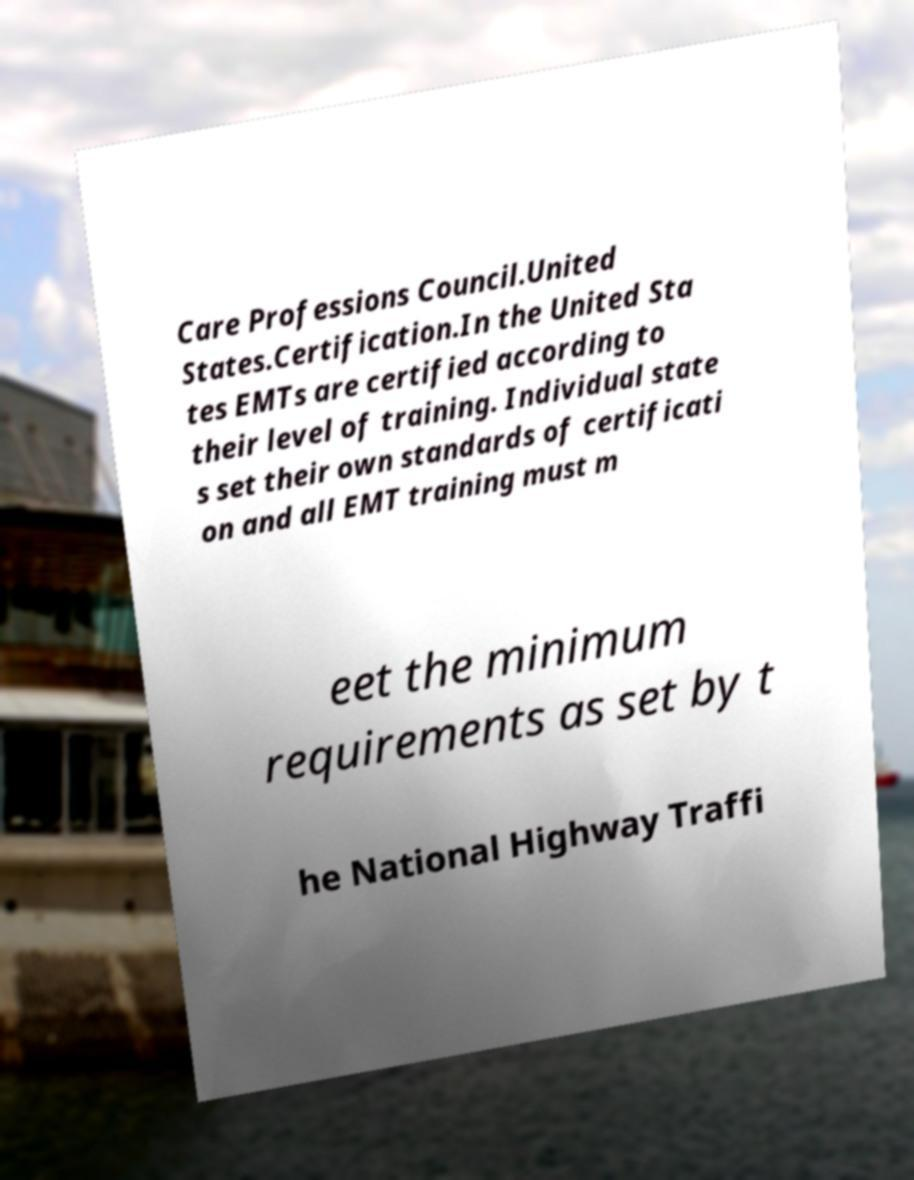Could you extract and type out the text from this image? Care Professions Council.United States.Certification.In the United Sta tes EMTs are certified according to their level of training. Individual state s set their own standards of certificati on and all EMT training must m eet the minimum requirements as set by t he National Highway Traffi 